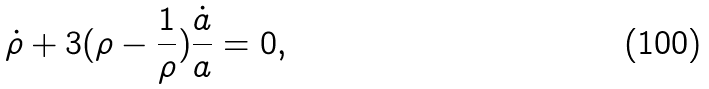Convert formula to latex. <formula><loc_0><loc_0><loc_500><loc_500>\dot { \rho } + 3 ( \rho - \frac { 1 } { \rho } ) \frac { \dot { a } } { a } = 0 ,</formula> 